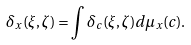Convert formula to latex. <formula><loc_0><loc_0><loc_500><loc_500>\delta _ { x } ( \xi , \zeta ) = \int \delta _ { c } ( \xi , \zeta ) d \mu _ { x } ( c ) .</formula> 